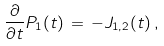<formula> <loc_0><loc_0><loc_500><loc_500>\frac { \partial } { \partial t } P _ { 1 } ( t ) \, = \, - J _ { 1 , 2 } ( t ) \, ,</formula> 